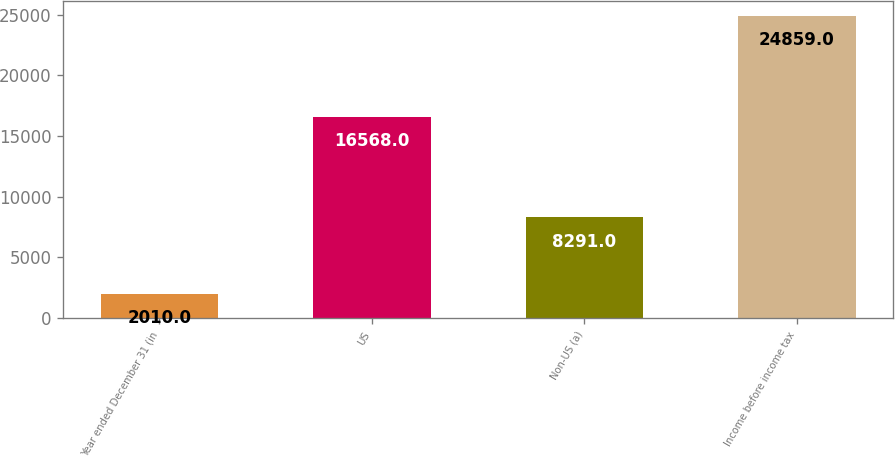<chart> <loc_0><loc_0><loc_500><loc_500><bar_chart><fcel>Year ended December 31 (in<fcel>US<fcel>Non-US (a)<fcel>Income before income tax<nl><fcel>2010<fcel>16568<fcel>8291<fcel>24859<nl></chart> 